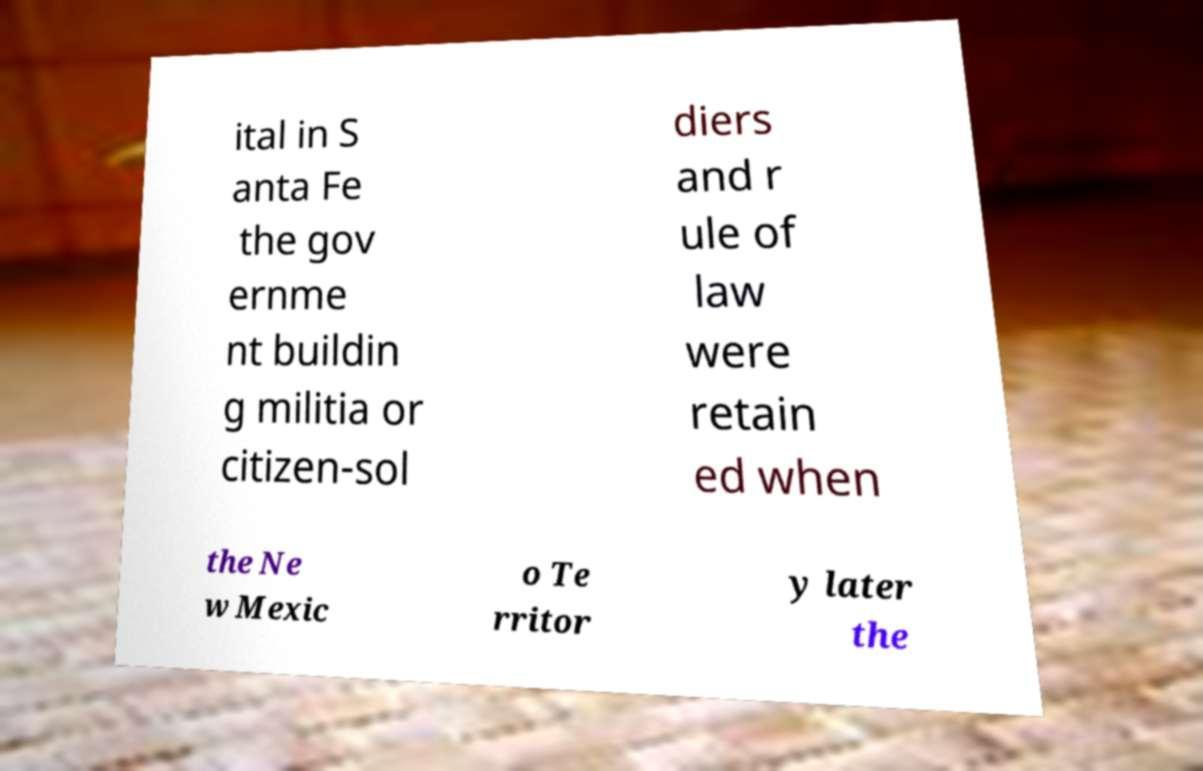Can you read and provide the text displayed in the image?This photo seems to have some interesting text. Can you extract and type it out for me? ital in S anta Fe the gov ernme nt buildin g militia or citizen-sol diers and r ule of law were retain ed when the Ne w Mexic o Te rritor y later the 